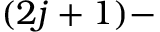<formula> <loc_0><loc_0><loc_500><loc_500>( 2 j + 1 ) -</formula> 